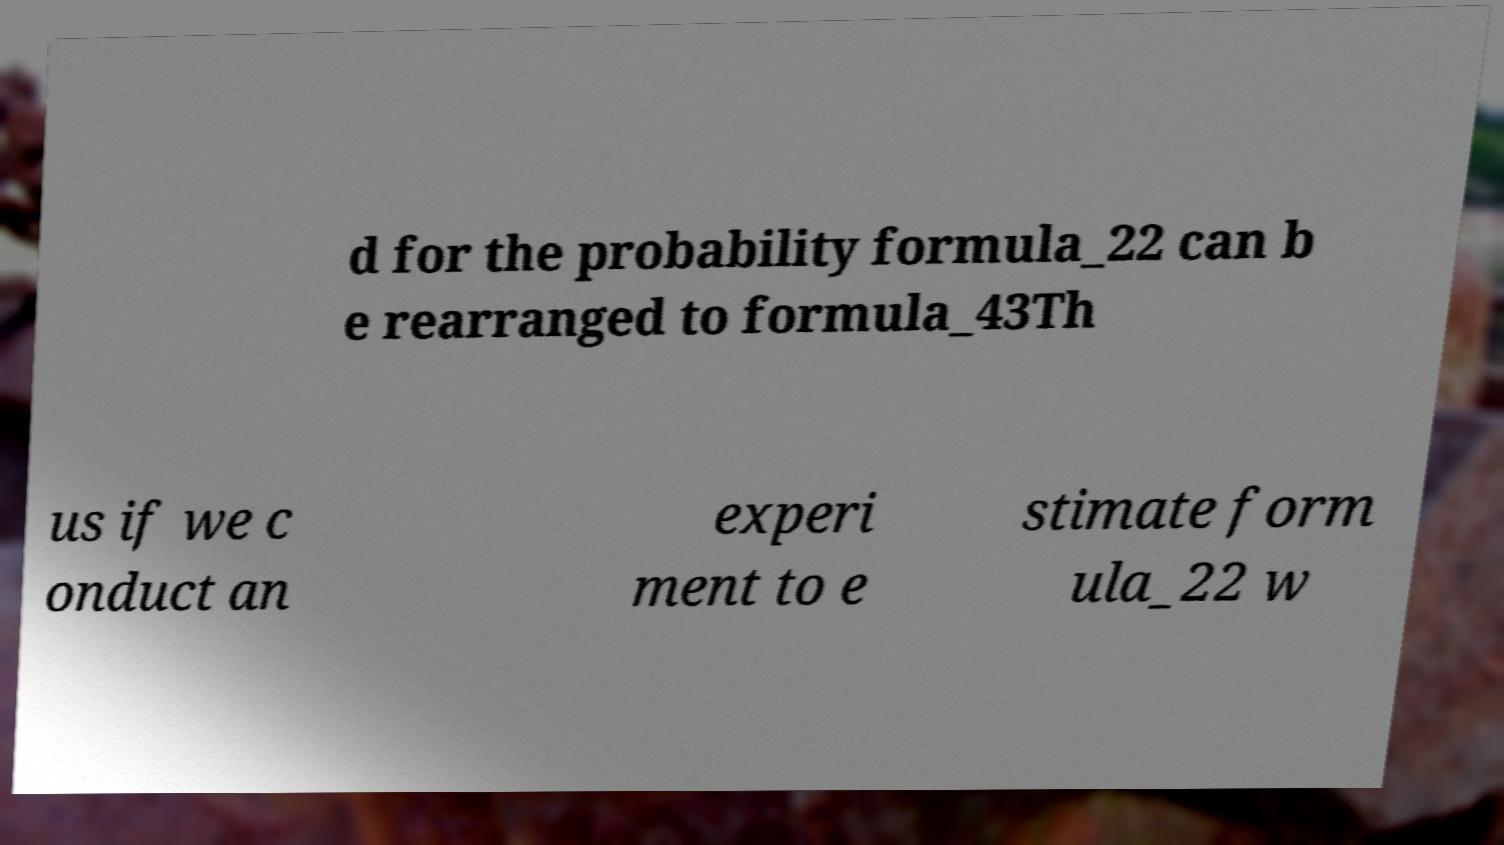Please read and relay the text visible in this image. What does it say? d for the probability formula_22 can b e rearranged to formula_43Th us if we c onduct an experi ment to e stimate form ula_22 w 